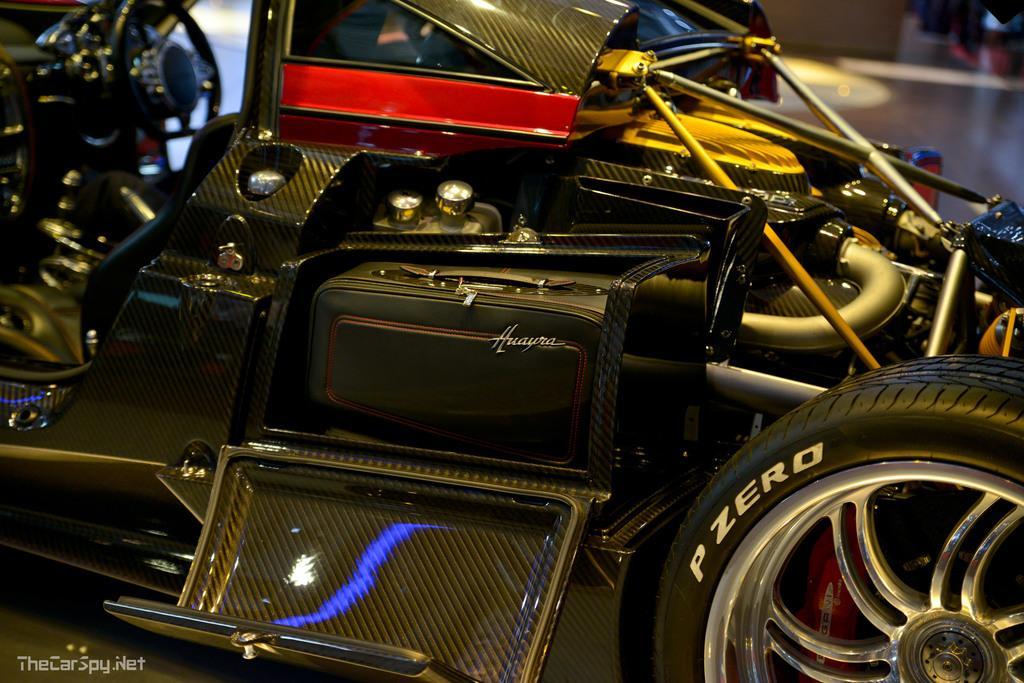Describe this image in one or two sentences. In this image, in the right side corner, we can see a tyre. In the middle of the image, we can see some vehicles and metal instruments, 